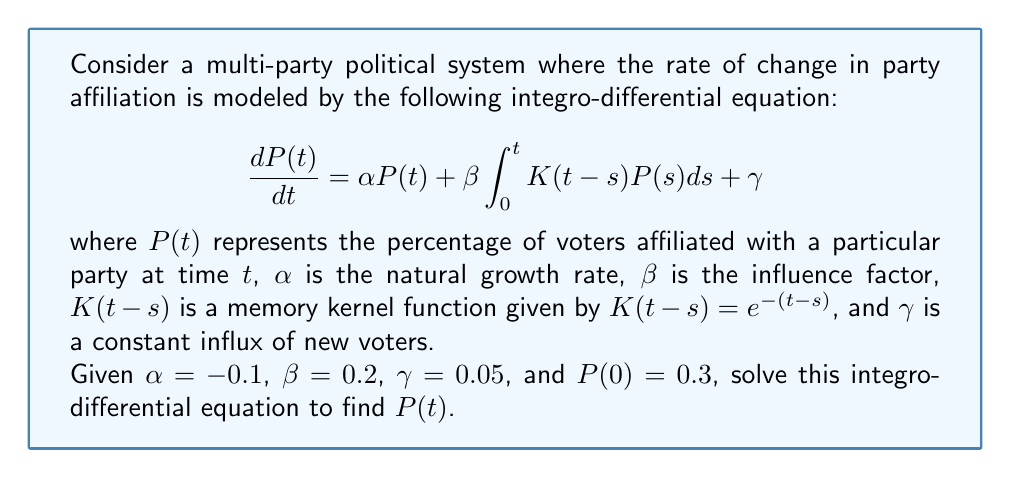Can you solve this math problem? To solve this integro-differential equation, we'll use the Laplace transform method:

1) Take the Laplace transform of both sides:
   $$\mathcal{L}\left\{\frac{dP(t)}{dt}\right\} = \mathcal{L}\{\alpha P(t)\} + \mathcal{L}\left\{\beta \int_0^t K(t-s)P(s)ds\right\} + \mathcal{L}\{\gamma\}$$

2) Using Laplace transform properties:
   $$s\tilde{P}(s) - P(0) = \alpha \tilde{P}(s) + \beta \tilde{K}(s)\tilde{P}(s) + \frac{\gamma}{s}$$

   where $\tilde{P}(s)$ is the Laplace transform of $P(t)$ and $\tilde{K}(s)$ is the Laplace transform of $K(t)$.

3) The Laplace transform of $K(t) = e^{-t}$ is $\tilde{K}(s) = \frac{1}{s+1}$.

4) Substituting and rearranging:
   $$s\tilde{P}(s) - 0.3 = -0.1\tilde{P}(s) + 0.2\frac{1}{s+1}\tilde{P}(s) + \frac{0.05}{s}$$

5) Solve for $\tilde{P}(s)$:
   $$\tilde{P}(s) = \frac{0.3s + 0.05}{s^2 + 1.1s - 0.2}$$

6) Decompose into partial fractions:
   $$\tilde{P}(s) = \frac{A}{s-r_1} + \frac{B}{s-r_2}$$

   where $r_1$ and $r_2$ are the roots of $s^2 + 1.1s - 0.2 = 0$.

7) Solving, we get $r_1 \approx -1.2749$ and $r_2 \approx 0.1749$.
   $A \approx 0.3628$ and $B \approx -0.0628$.

8) Take the inverse Laplace transform:
   $$P(t) = 0.3628e^{0.1749t} - 0.0628e^{-1.2749t}$$

This is the solution to the integro-differential equation.
Answer: $P(t) = 0.3628e^{0.1749t} - 0.0628e^{-1.2749t}$ 